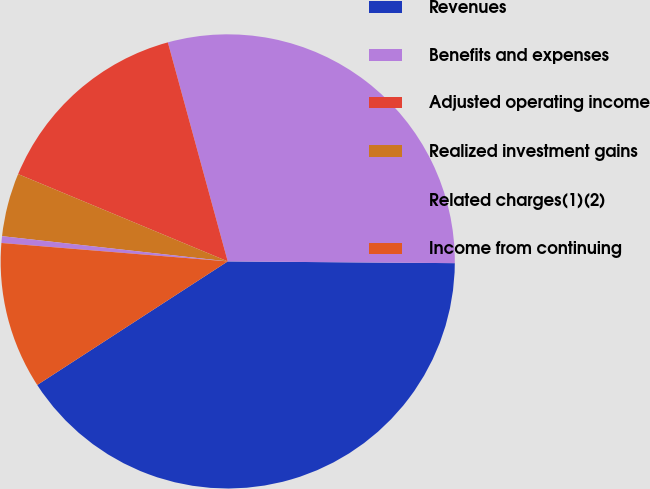Convert chart. <chart><loc_0><loc_0><loc_500><loc_500><pie_chart><fcel>Revenues<fcel>Benefits and expenses<fcel>Adjusted operating income<fcel>Realized investment gains<fcel>Related charges(1)(2)<fcel>Income from continuing<nl><fcel>40.72%<fcel>29.37%<fcel>14.47%<fcel>4.51%<fcel>0.48%<fcel>10.45%<nl></chart> 